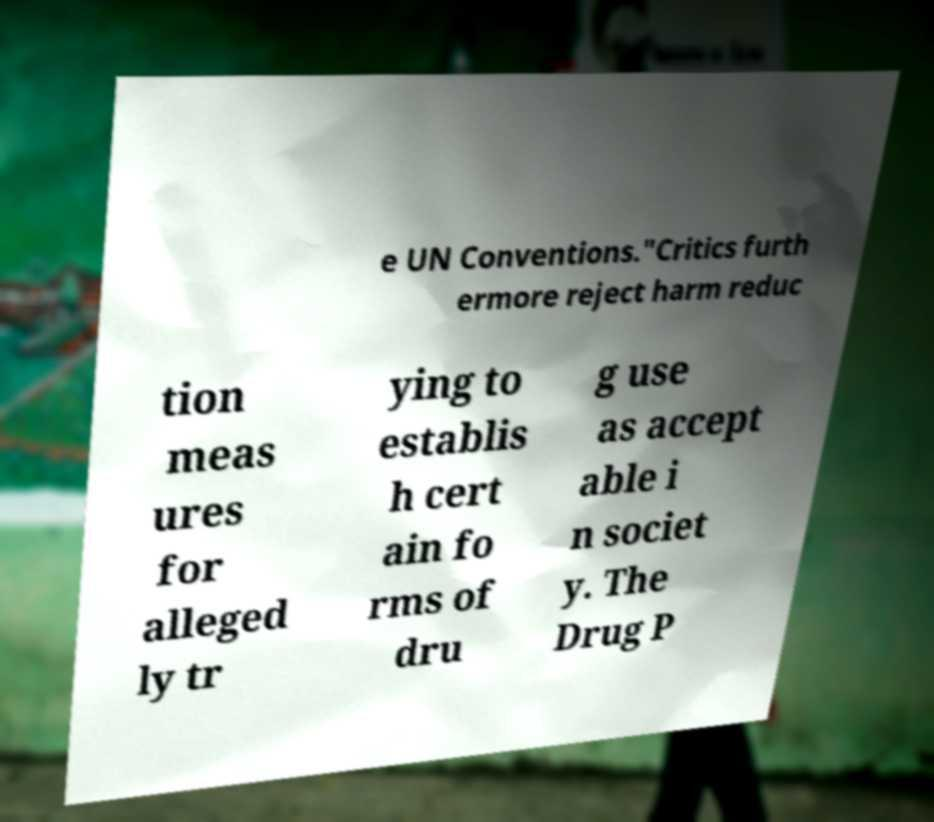Please read and relay the text visible in this image. What does it say? e UN Conventions."Critics furth ermore reject harm reduc tion meas ures for alleged ly tr ying to establis h cert ain fo rms of dru g use as accept able i n societ y. The Drug P 